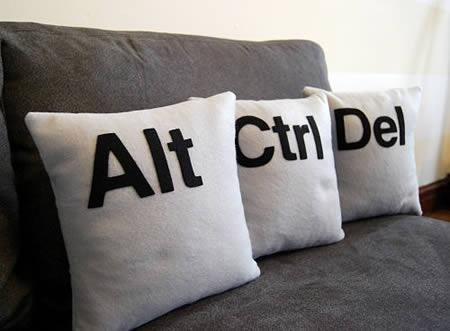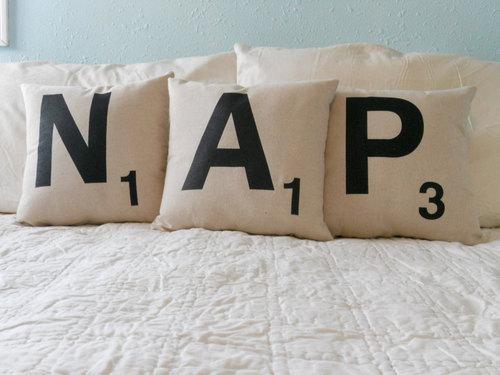The first image is the image on the left, the second image is the image on the right. Assess this claim about the two images: "Every throw pillow pictured is square and whitish with at least one black letter on it, and each image contains exactly three throw pillows.". Correct or not? Answer yes or no. Yes. The first image is the image on the left, the second image is the image on the right. Analyze the images presented: Is the assertion "All of the pillows are computer related." valid? Answer yes or no. No. 